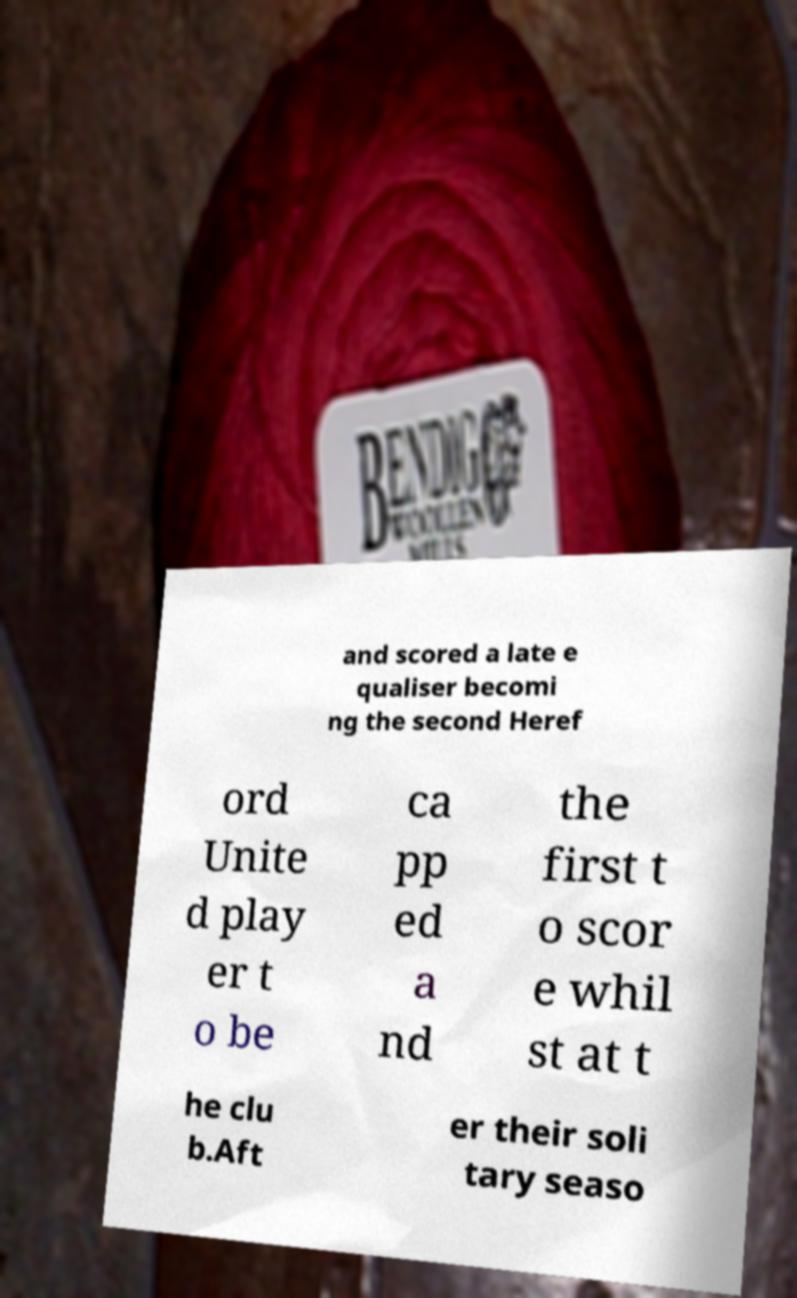I need the written content from this picture converted into text. Can you do that? and scored a late e qualiser becomi ng the second Heref ord Unite d play er t o be ca pp ed a nd the first t o scor e whil st at t he clu b.Aft er their soli tary seaso 